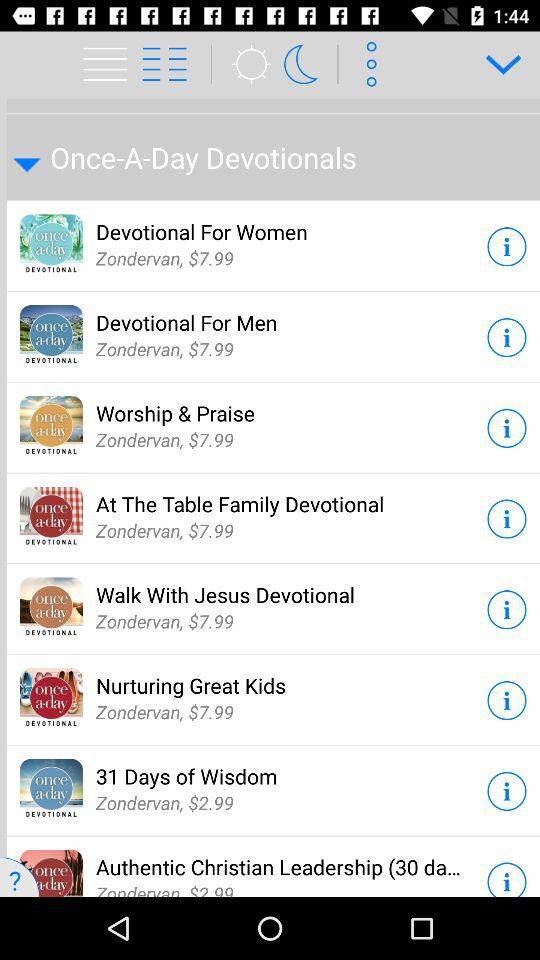What's the cost of "Devotional for Men"? The cost is $7.99. 